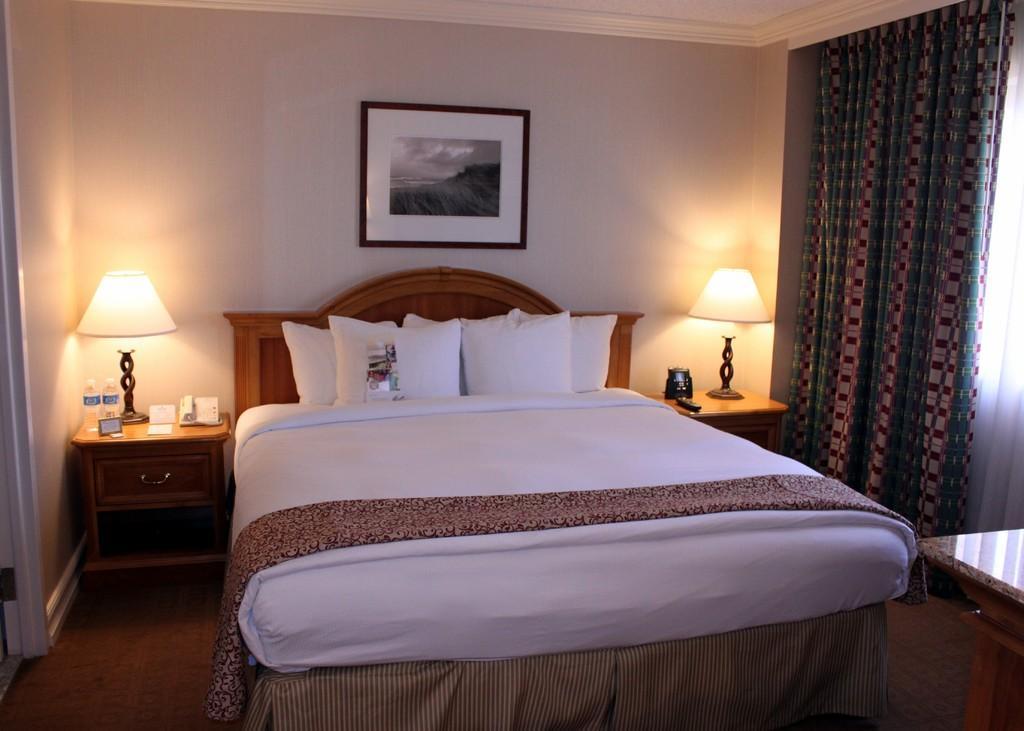Please provide a concise description of this image. This image is taken inside a room. This room consists of a bed, a blanket, pillow and a bed sheet on it. In the left side of the image there is a drawer, on that there is a lamp, water bottles, paper and telephone. In the right side of the image there is a wall with curtains. At the top of the image there is a ceiling. At the background there is a wall with a frame on it. 